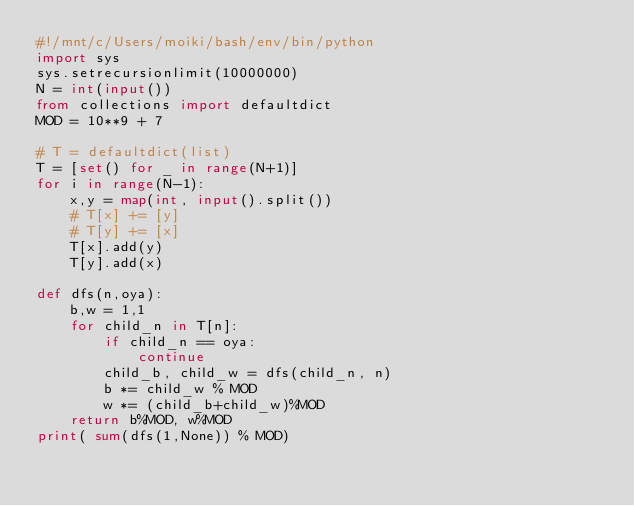<code> <loc_0><loc_0><loc_500><loc_500><_Python_>#!/mnt/c/Users/moiki/bash/env/bin/python
import sys
sys.setrecursionlimit(10000000)
N = int(input())
from collections import defaultdict
MOD = 10**9 + 7

# T = defaultdict(list)
T = [set() for _ in range(N+1)]
for i in range(N-1):
    x,y = map(int, input().split())
    # T[x] += [y]
    # T[y] += [x]
    T[x].add(y)
    T[y].add(x)

def dfs(n,oya):
    b,w = 1,1
    for child_n in T[n]:
        if child_n == oya:
            continue
        child_b, child_w = dfs(child_n, n)
        b *= child_w % MOD
        w *= (child_b+child_w)%MOD
    return b%MOD, w%MOD
print( sum(dfs(1,None)) % MOD) 

</code> 